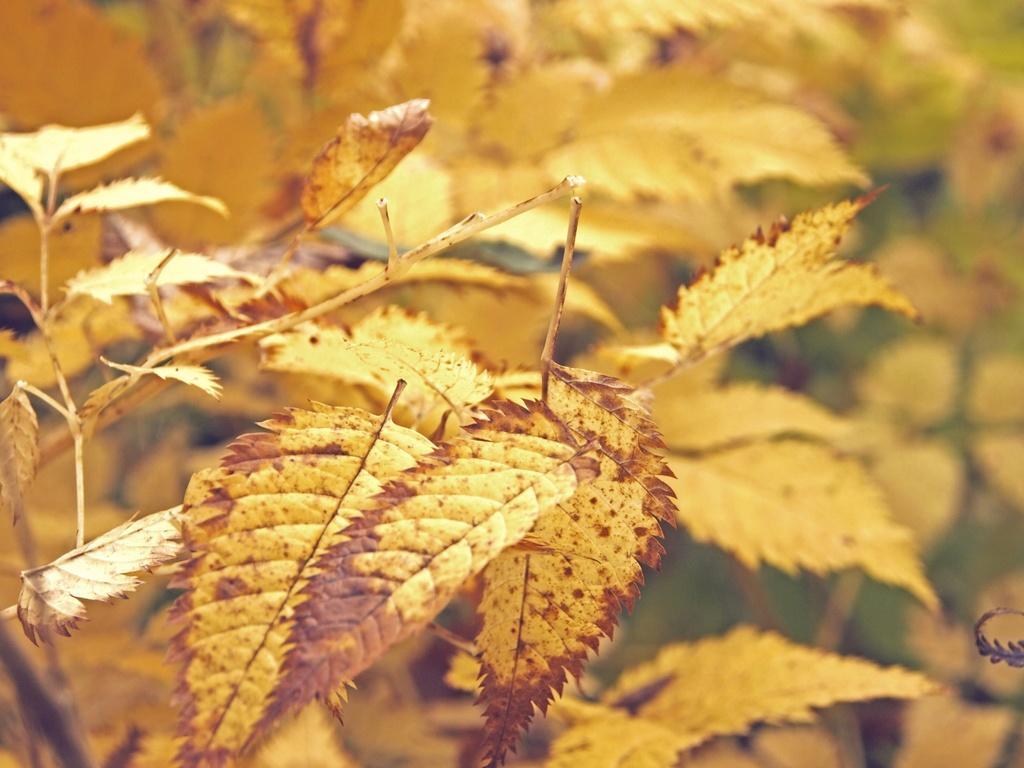Describe this image in one or two sentences. In this picture we can see the dry leaves and the stems of the plants. 